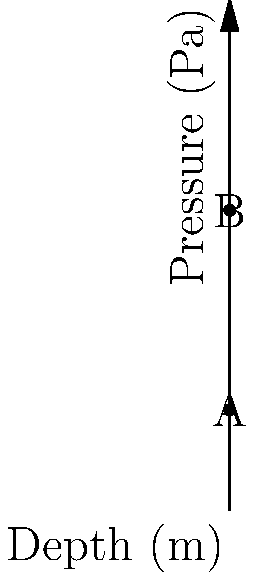In a mining operation, we need to calculate the hydrostatic pressure at different depths in water-filled tunnels. The graph shows the relationship between depth and pressure. If the pressure at point A (100m depth) is 981,000 Pa, what is the pressure at point B (300m depth)? Assume the density of water is 1000 kg/m³ and g = 9.81 m/s². To solve this problem, we'll use the following steps:

1) The hydrostatic pressure is given by the formula:
   $$P = \rho g h$$
   where $\rho$ is the density of the fluid, $g$ is the acceleration due to gravity, and $h$ is the depth.

2) We're given that $\rho = 1000$ kg/m³ and $g = 9.81$ m/s².

3) For point A (100m depth):
   $$P_A = 1000 \times 9.81 \times 100 = 981,000 \text{ Pa}$$
   This confirms the given information.

4) For point B (300m depth):
   $$P_B = 1000 \times 9.81 \times 300 = 2,943,000 \text{ Pa}$$

5) We can verify this result by observing that the depth has tripled (from 100m to 300m), so the pressure should also triple.

   Indeed, $981,000 \times 3 = 2,943,000$ Pa.

Therefore, the pressure at point B (300m depth) is 2,943,000 Pa.
Answer: 2,943,000 Pa 